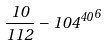Convert formula to latex. <formula><loc_0><loc_0><loc_500><loc_500>\frac { 1 0 } { 1 1 2 } - { 1 0 4 ^ { 4 0 } } ^ { 6 }</formula> 